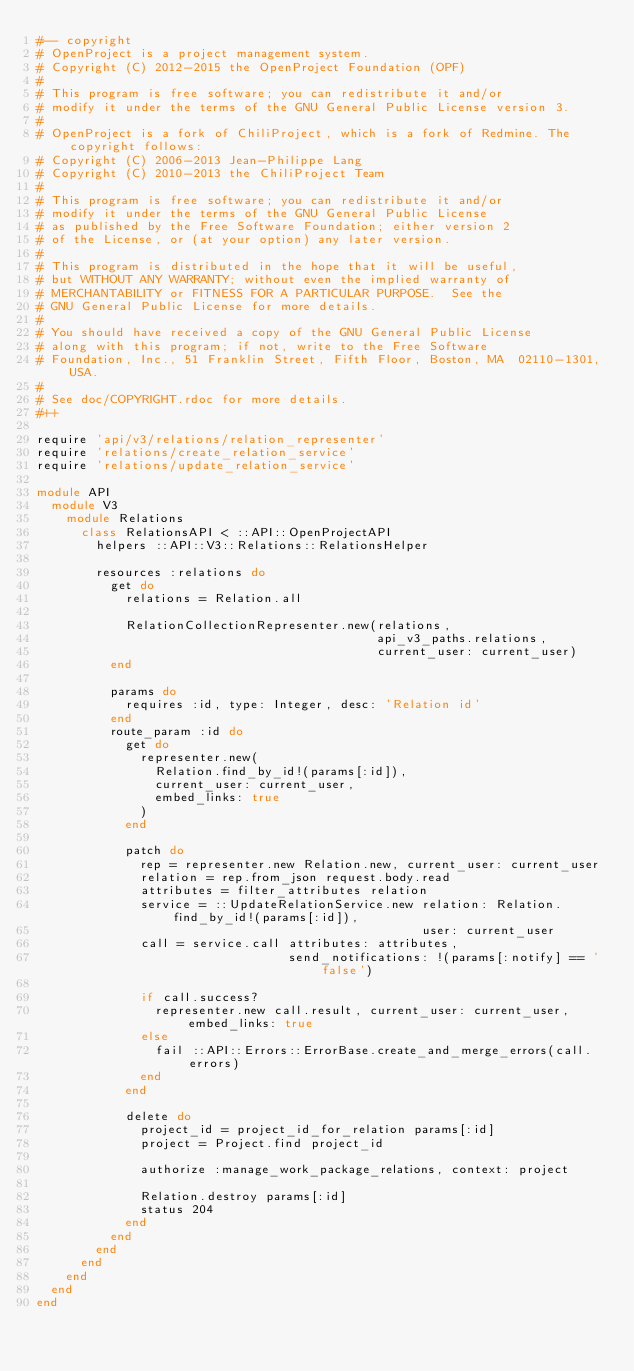<code> <loc_0><loc_0><loc_500><loc_500><_Ruby_>#-- copyright
# OpenProject is a project management system.
# Copyright (C) 2012-2015 the OpenProject Foundation (OPF)
#
# This program is free software; you can redistribute it and/or
# modify it under the terms of the GNU General Public License version 3.
#
# OpenProject is a fork of ChiliProject, which is a fork of Redmine. The copyright follows:
# Copyright (C) 2006-2013 Jean-Philippe Lang
# Copyright (C) 2010-2013 the ChiliProject Team
#
# This program is free software; you can redistribute it and/or
# modify it under the terms of the GNU General Public License
# as published by the Free Software Foundation; either version 2
# of the License, or (at your option) any later version.
#
# This program is distributed in the hope that it will be useful,
# but WITHOUT ANY WARRANTY; without even the implied warranty of
# MERCHANTABILITY or FITNESS FOR A PARTICULAR PURPOSE.  See the
# GNU General Public License for more details.
#
# You should have received a copy of the GNU General Public License
# along with this program; if not, write to the Free Software
# Foundation, Inc., 51 Franklin Street, Fifth Floor, Boston, MA  02110-1301, USA.
#
# See doc/COPYRIGHT.rdoc for more details.
#++

require 'api/v3/relations/relation_representer'
require 'relations/create_relation_service'
require 'relations/update_relation_service'

module API
  module V3
    module Relations
      class RelationsAPI < ::API::OpenProjectAPI
        helpers ::API::V3::Relations::RelationsHelper

        resources :relations do
          get do
            relations = Relation.all

            RelationCollectionRepresenter.new(relations,
                                              api_v3_paths.relations,
                                              current_user: current_user)
          end

          params do
            requires :id, type: Integer, desc: 'Relation id'
          end
          route_param :id do
            get do
              representer.new(
                Relation.find_by_id!(params[:id]),
                current_user: current_user,
                embed_links: true
              )
            end

            patch do
              rep = representer.new Relation.new, current_user: current_user
              relation = rep.from_json request.body.read
              attributes = filter_attributes relation
              service = ::UpdateRelationService.new relation: Relation.find_by_id!(params[:id]),
                                                    user: current_user
              call = service.call attributes: attributes,
                                  send_notifications: !(params[:notify] == 'false')

              if call.success?
                representer.new call.result, current_user: current_user, embed_links: true
              else
                fail ::API::Errors::ErrorBase.create_and_merge_errors(call.errors)
              end
            end

            delete do
              project_id = project_id_for_relation params[:id]
              project = Project.find project_id

              authorize :manage_work_package_relations, context: project

              Relation.destroy params[:id]
              status 204
            end
          end
        end
      end
    end
  end
end
</code> 